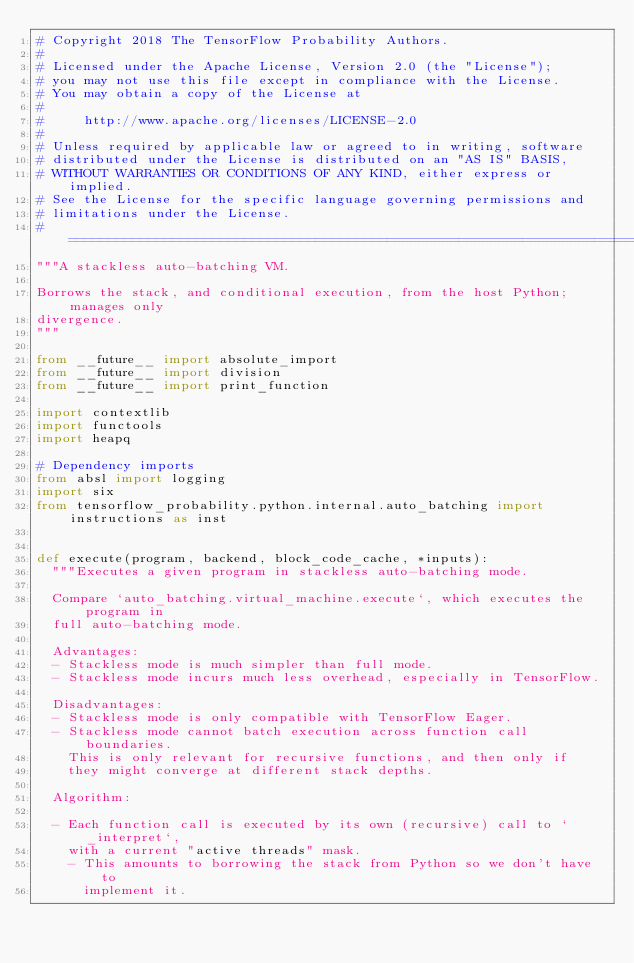Convert code to text. <code><loc_0><loc_0><loc_500><loc_500><_Python_># Copyright 2018 The TensorFlow Probability Authors.
#
# Licensed under the Apache License, Version 2.0 (the "License");
# you may not use this file except in compliance with the License.
# You may obtain a copy of the License at
#
#     http://www.apache.org/licenses/LICENSE-2.0
#
# Unless required by applicable law or agreed to in writing, software
# distributed under the License is distributed on an "AS IS" BASIS,
# WITHOUT WARRANTIES OR CONDITIONS OF ANY KIND, either express or implied.
# See the License for the specific language governing permissions and
# limitations under the License.
# ============================================================================
"""A stackless auto-batching VM.

Borrows the stack, and conditional execution, from the host Python; manages only
divergence.
"""

from __future__ import absolute_import
from __future__ import division
from __future__ import print_function

import contextlib
import functools
import heapq

# Dependency imports
from absl import logging
import six
from tensorflow_probability.python.internal.auto_batching import instructions as inst


def execute(program, backend, block_code_cache, *inputs):
  """Executes a given program in stackless auto-batching mode.

  Compare `auto_batching.virtual_machine.execute`, which executes the program in
  full auto-batching mode.

  Advantages:
  - Stackless mode is much simpler than full mode.
  - Stackless mode incurs much less overhead, especially in TensorFlow.

  Disadvantages:
  - Stackless mode is only compatible with TensorFlow Eager.
  - Stackless mode cannot batch execution across function call boundaries.
    This is only relevant for recursive functions, and then only if
    they might converge at different stack depths.

  Algorithm:

  - Each function call is executed by its own (recursive) call to `_interpret`,
    with a current "active threads" mask.
    - This amounts to borrowing the stack from Python so we don't have to
      implement it.</code> 